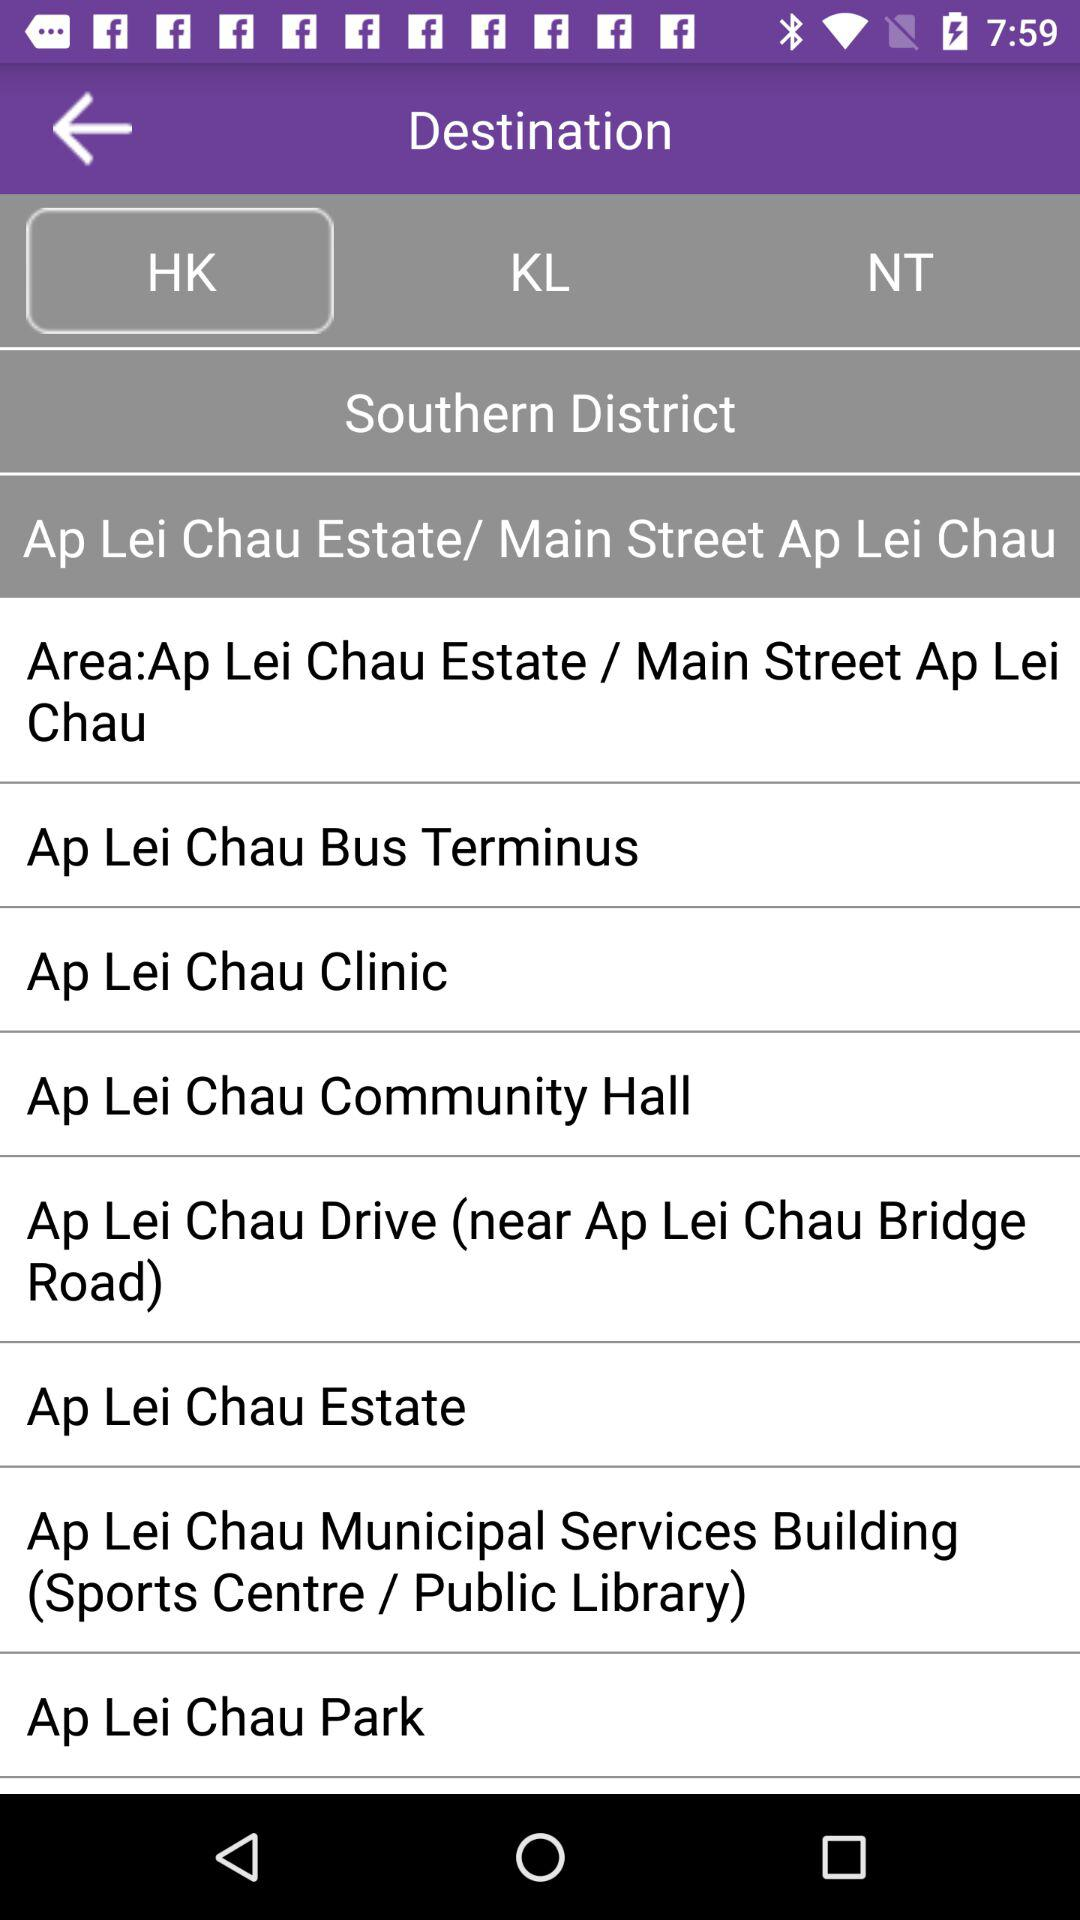What's the district? The district is southern. 